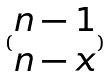<formula> <loc_0><loc_0><loc_500><loc_500>( \begin{matrix} n - 1 \\ n - x \end{matrix} )</formula> 